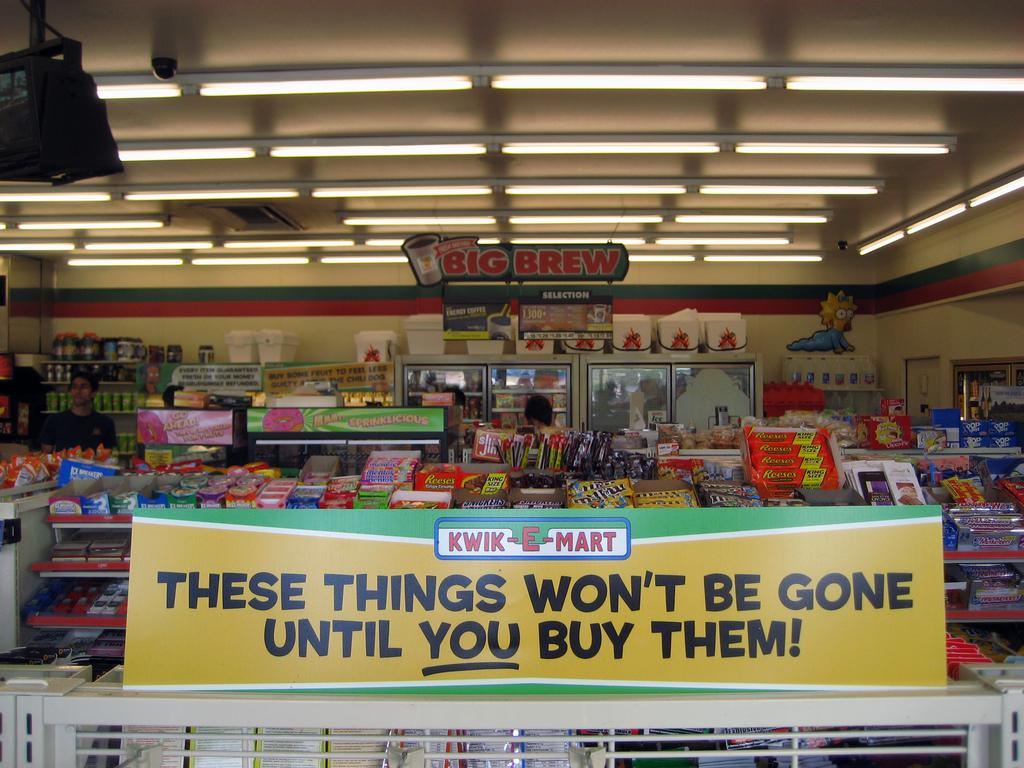<image>
Present a compact description of the photo's key features. A sign in front of a Kwik E Mart that says these things won't be gone until you buy them. 